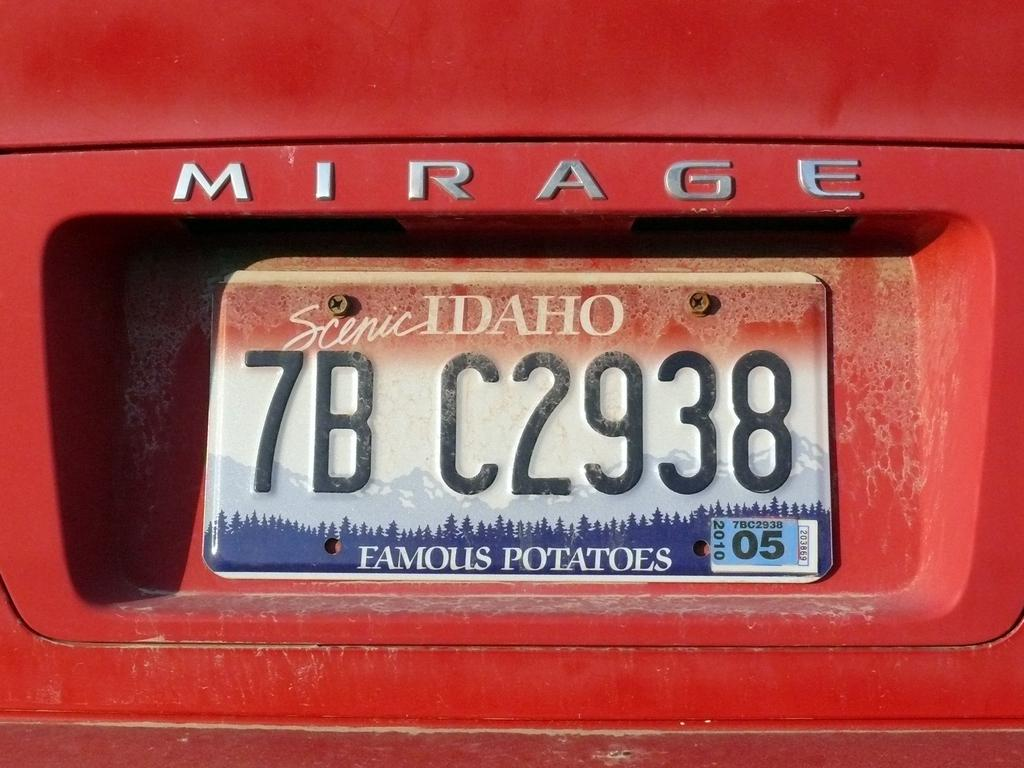<image>
Relay a brief, clear account of the picture shown. A red Mirage car with a license plate from Idaho. 